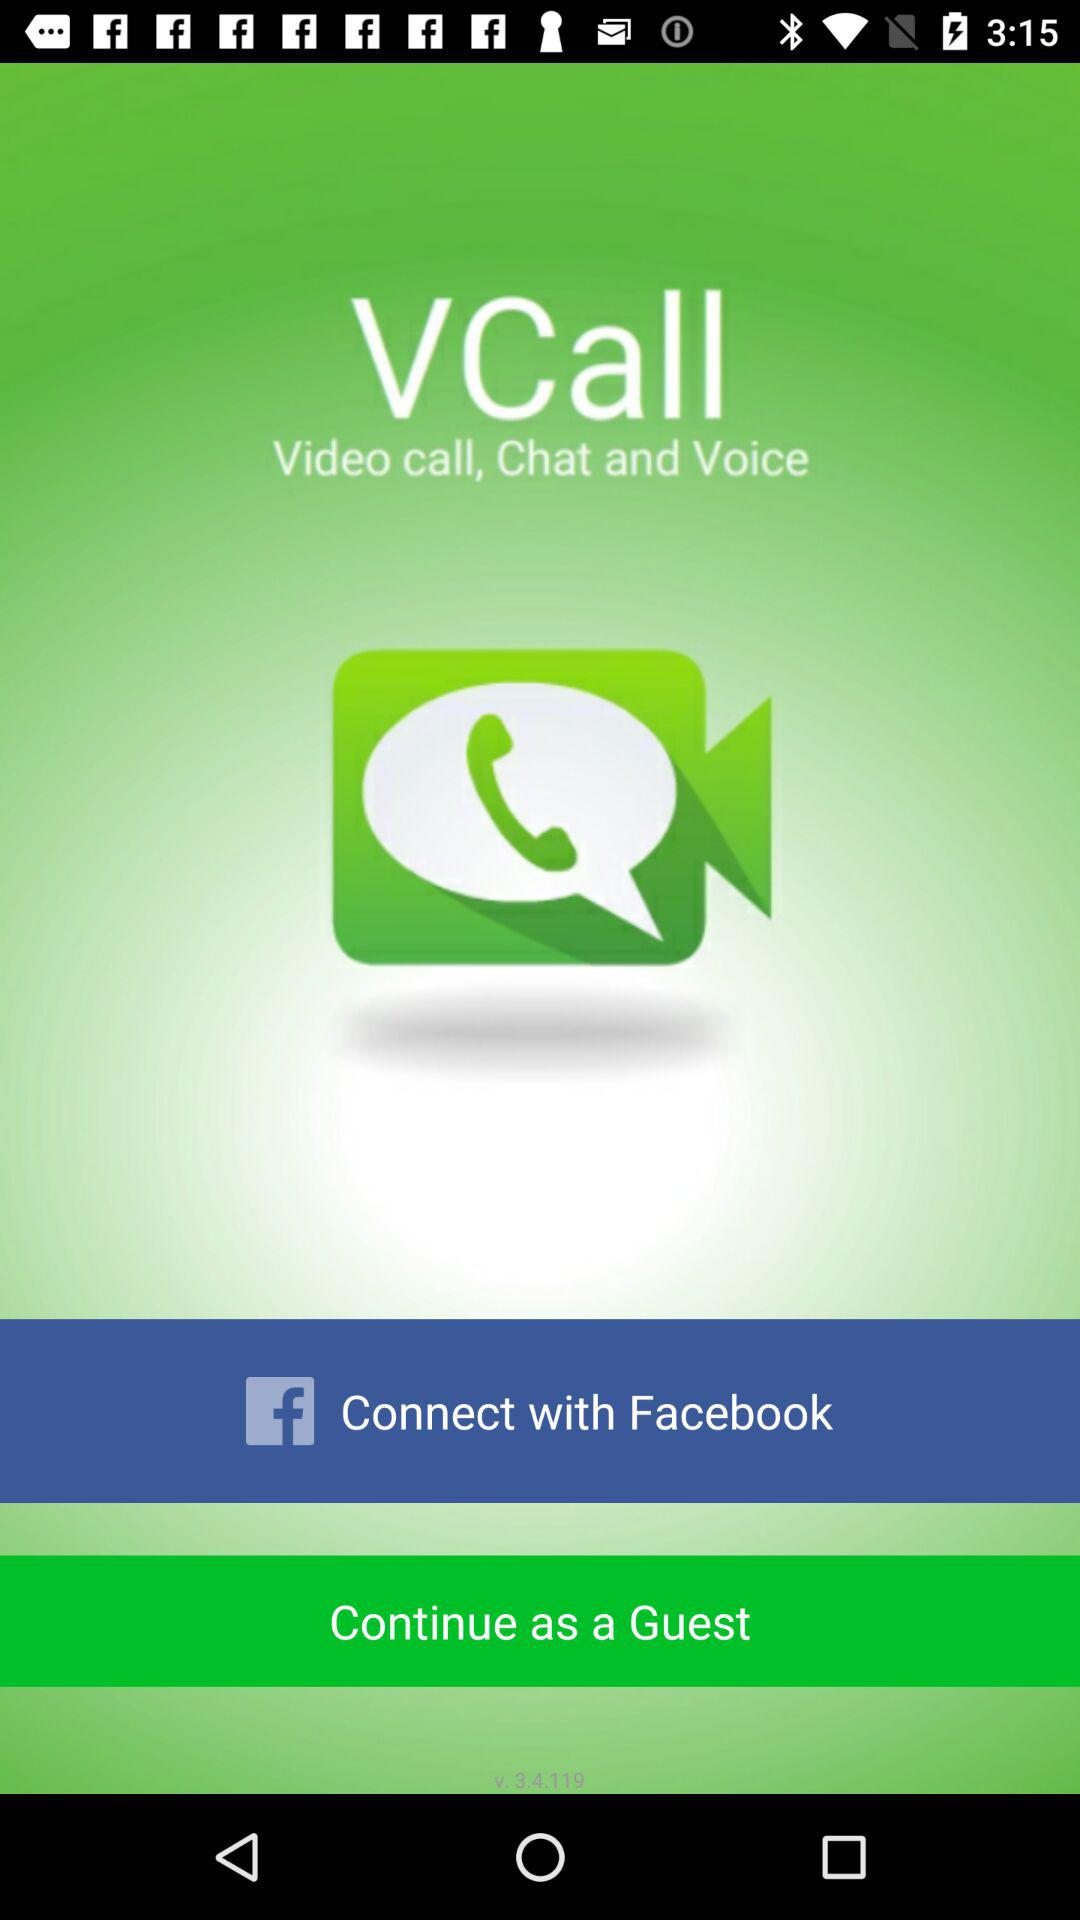Through what application can a user continue with? The user can continue with Facebook. 